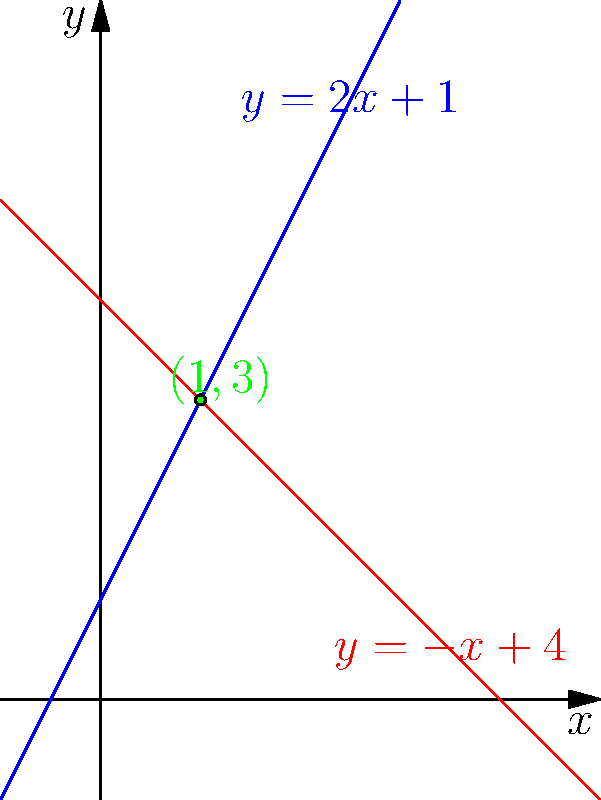Найдите точку пересечения двух прямых, заданных уравнениями $y = 2x + 1$ и $y = -x + 4$. Запишите ответ в формате $(x, y)$. Для нахождения точки пересечения двух прямых нужно решить систему уравнений:

$$\begin{cases}
y = 2x + 1 \\
y = -x + 4
\end{cases}$$

Шаги решения:
1) Приравняем правые части уравнений:
   $$2x + 1 = -x + 4$$

2) Решим получившееся уравнение:
   $$2x + 1 = -x + 4$$
   $$3x = 3$$
   $$x = 1$$

3) Подставим найденное значение $x$ в любое из исходных уравнений, например, в первое:
   $$y = 2(1) + 1 = 2 + 1 = 3$$

4) Таким образом, координаты точки пересечения: $(1, 3)$

Проверка: подставим полученные координаты в оба уравнения:
- $y = 2x + 1$: $3 = 2(1) + 1$ (верно)
- $y = -x + 4$: $3 = -1 + 4$ (верно)
Answer: $(1, 3)$ 